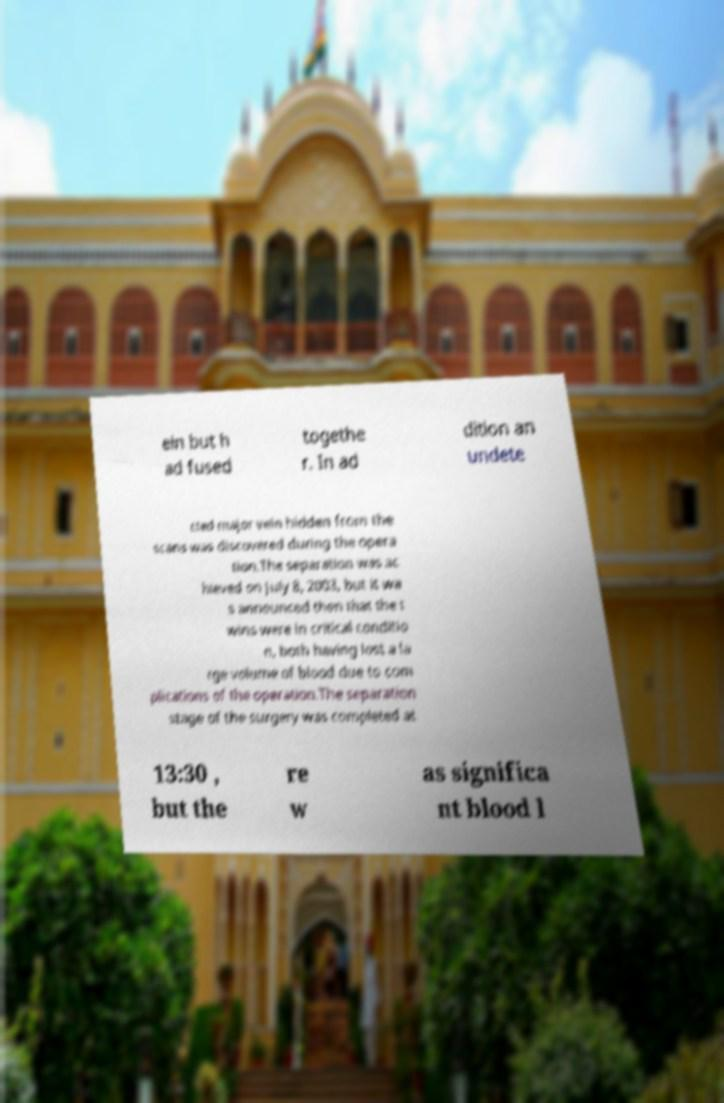For documentation purposes, I need the text within this image transcribed. Could you provide that? ein but h ad fused togethe r. In ad dition an undete cted major vein hidden from the scans was discovered during the opera tion.The separation was ac hieved on July 8, 2003, but it wa s announced then that the t wins were in critical conditio n, both having lost a la rge volume of blood due to com plications of the operation.The separation stage of the surgery was completed at 13:30 , but the re w as significa nt blood l 